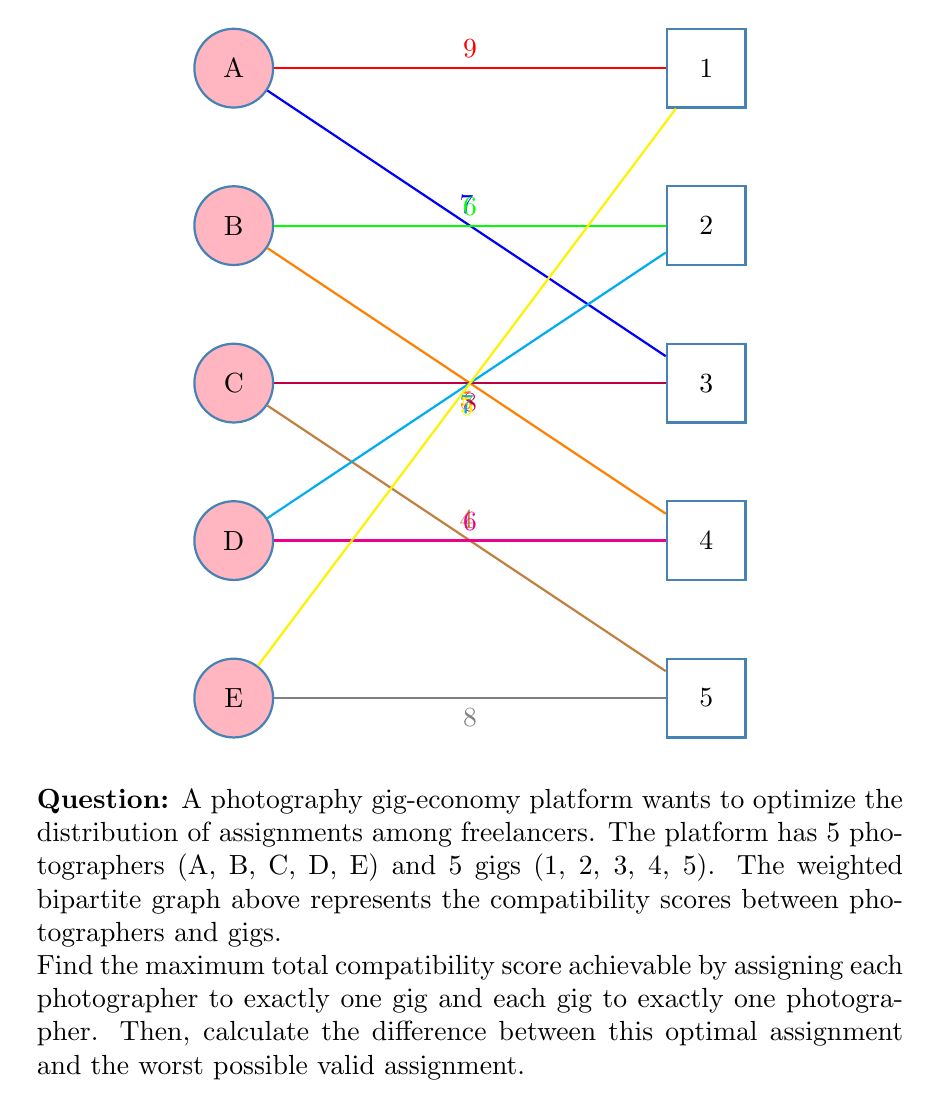Give your solution to this math problem. To solve this problem, we'll use the Hungarian algorithm for maximum weighted matching in bipartite graphs. Here's a step-by-step solution:

1) First, let's create the complete weighted matrix:

   $$
   \begin{bmatrix}
   9 & 0 & 7 & 0 & 0 \\
   0 & 6 & 0 & 5 & 0 \\
   0 & 0 & 8 & 0 & 4 \\
   0 & 7 & 0 & 6 & 0 \\
   5 & 0 & 0 & 0 & 8
   \end{bmatrix}
   $$

2) Apply the Hungarian algorithm:
   - Subtract the row minimum from each row
   - Subtract the column minimum from each column
   - Find the minimum number of lines to cover all zeros
   - If the number of lines equals the matrix size, we're done. Otherwise, subtract the minimum uncovered value from all uncovered elements and add it to elements covered twice.

3) After applying the algorithm, we get the optimal assignment:
   A → 1 (9)
   B → 3 (5)
   C → 2 (8)
   D → 4 (6)
   E → 5 (8)

4) The maximum total compatibility score is: 9 + 5 + 8 + 6 + 8 = 36

5) For the worst possible assignment, we need to find the minimum weight matching:
   A → 3 (7)
   B → 4 (5)
   C → 5 (4)
   D → 1 (0)
   E → 2 (0)

6) The minimum total compatibility score is: 7 + 5 + 4 + 0 + 0 = 16

7) The difference between the optimal and worst assignments is: 36 - 16 = 20
Answer: 20 